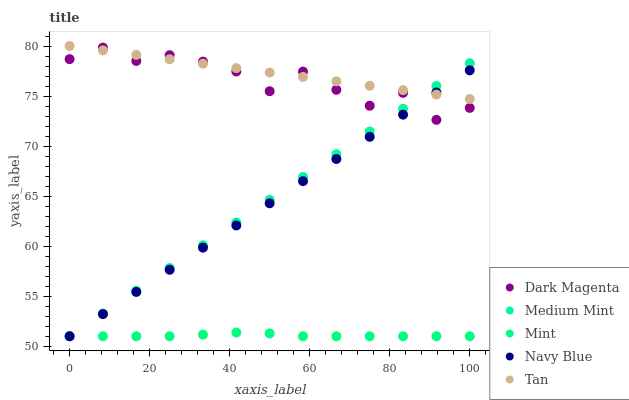Does Mint have the minimum area under the curve?
Answer yes or no. Yes. Does Tan have the maximum area under the curve?
Answer yes or no. Yes. Does Navy Blue have the minimum area under the curve?
Answer yes or no. No. Does Navy Blue have the maximum area under the curve?
Answer yes or no. No. Is Tan the smoothest?
Answer yes or no. Yes. Is Dark Magenta the roughest?
Answer yes or no. Yes. Is Navy Blue the smoothest?
Answer yes or no. No. Is Navy Blue the roughest?
Answer yes or no. No. Does Medium Mint have the lowest value?
Answer yes or no. Yes. Does Tan have the lowest value?
Answer yes or no. No. Does Tan have the highest value?
Answer yes or no. Yes. Does Navy Blue have the highest value?
Answer yes or no. No. Is Mint less than Tan?
Answer yes or no. Yes. Is Dark Magenta greater than Mint?
Answer yes or no. Yes. Does Medium Mint intersect Navy Blue?
Answer yes or no. Yes. Is Medium Mint less than Navy Blue?
Answer yes or no. No. Is Medium Mint greater than Navy Blue?
Answer yes or no. No. Does Mint intersect Tan?
Answer yes or no. No. 